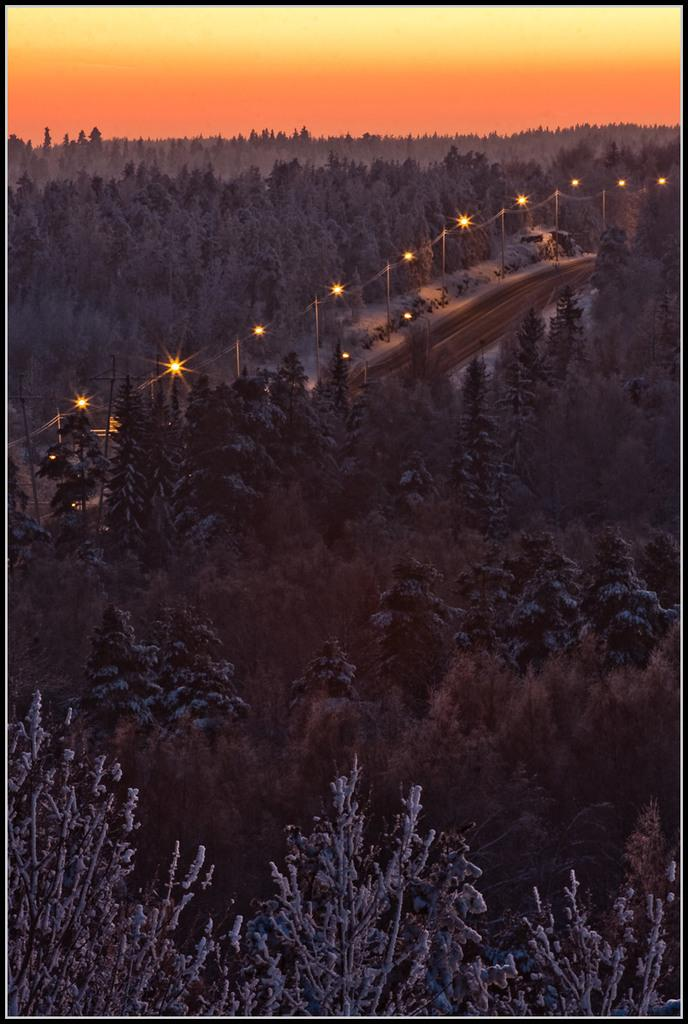What type of natural environment is depicted in the image? There is a large group of trees in the image. What man-made feature can be seen in the image? There is a pathway with street lights in the image. What can be seen in the background of the image? The sky is visible in the background of the image. Where is the cellar located in the image? There is no cellar present in the image. What type of recess can be seen in the image? There is no recess present in the image. 